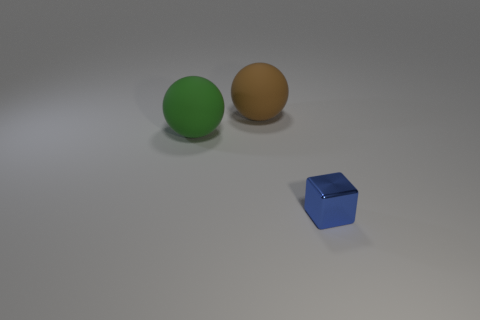What could be the material of the blue object? The blue object has a smooth and slightly shiny surface which might indicate that it's made of a material like plastic or polished metal. 